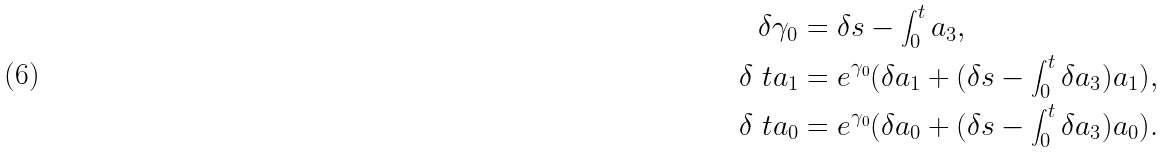Convert formula to latex. <formula><loc_0><loc_0><loc_500><loc_500>\delta \gamma _ { 0 } & = \delta s - \int _ { 0 } ^ { t } a _ { 3 } , \\ \delta \ t a _ { 1 } & = e ^ { \gamma _ { 0 } } ( \delta a _ { 1 } + ( \delta s - \int _ { 0 } ^ { t } \delta a _ { 3 } ) a _ { 1 } ) , \\ \delta \ t a _ { 0 } & = e ^ { \gamma _ { 0 } } ( \delta a _ { 0 } + ( \delta s - \int _ { 0 } ^ { t } \delta a _ { 3 } ) a _ { 0 } ) .</formula> 